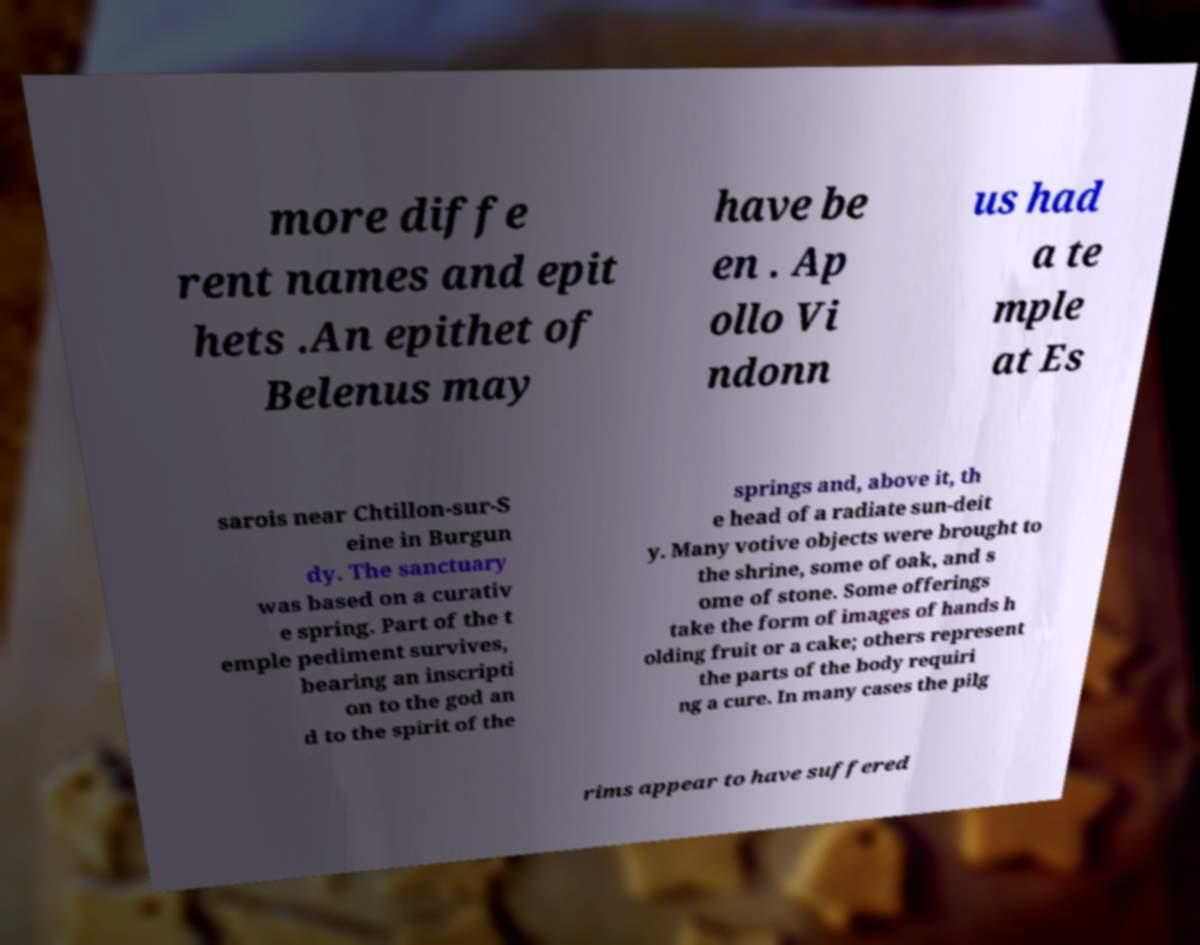Could you assist in decoding the text presented in this image and type it out clearly? more diffe rent names and epit hets .An epithet of Belenus may have be en . Ap ollo Vi ndonn us had a te mple at Es sarois near Chtillon-sur-S eine in Burgun dy. The sanctuary was based on a curativ e spring. Part of the t emple pediment survives, bearing an inscripti on to the god an d to the spirit of the springs and, above it, th e head of a radiate sun-deit y. Many votive objects were brought to the shrine, some of oak, and s ome of stone. Some offerings take the form of images of hands h olding fruit or a cake; others represent the parts of the body requiri ng a cure. In many cases the pilg rims appear to have suffered 